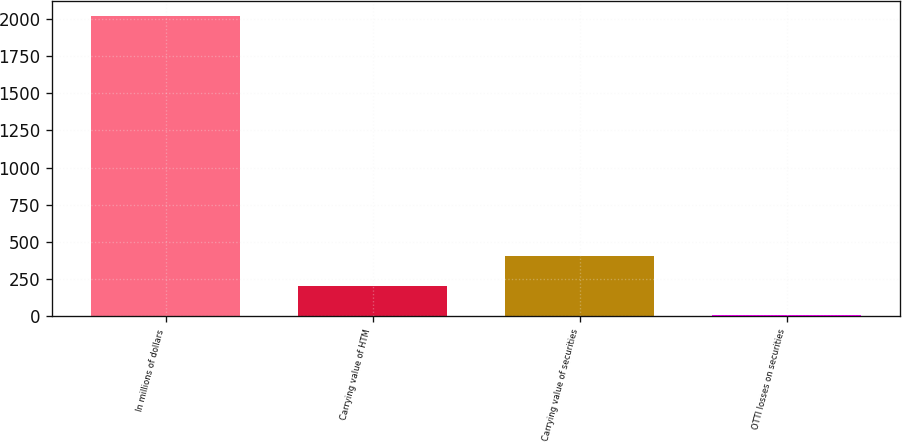Convert chart. <chart><loc_0><loc_0><loc_500><loc_500><bar_chart><fcel>In millions of dollars<fcel>Carrying value of HTM<fcel>Carrying value of securities<fcel>OTTI losses on securities<nl><fcel>2016<fcel>207<fcel>408<fcel>6<nl></chart> 